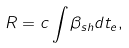<formula> <loc_0><loc_0><loc_500><loc_500>R = c \int \beta _ { s h } d t _ { e } ,</formula> 